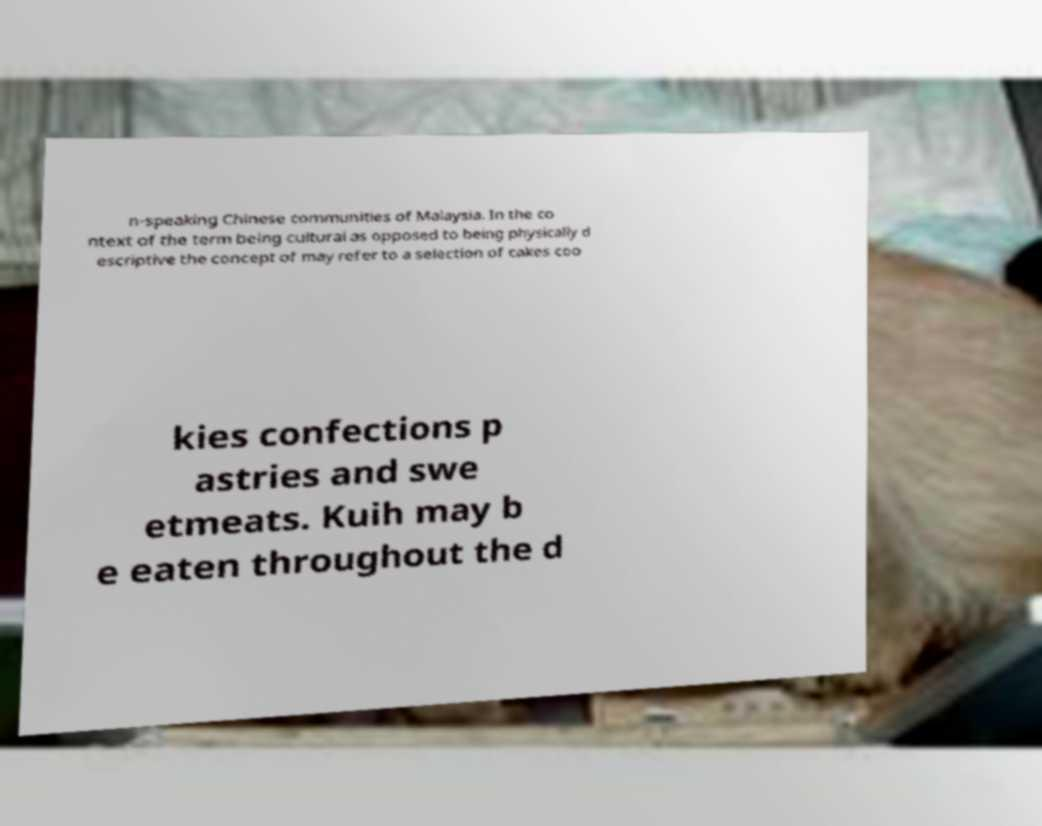There's text embedded in this image that I need extracted. Can you transcribe it verbatim? n-speaking Chinese communities of Malaysia. In the co ntext of the term being cultural as opposed to being physically d escriptive the concept of may refer to a selection of cakes coo kies confections p astries and swe etmeats. Kuih may b e eaten throughout the d 